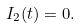<formula> <loc_0><loc_0><loc_500><loc_500>I _ { 2 } ( t ) = 0 .</formula> 